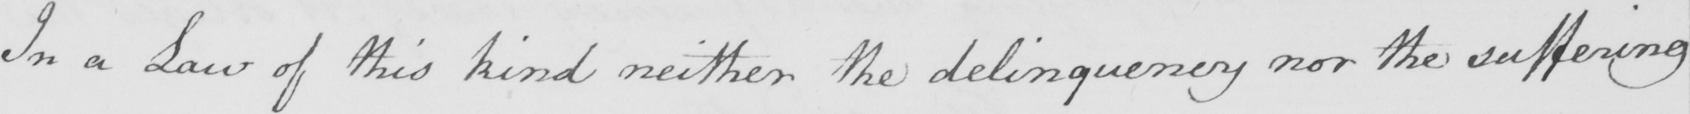Can you read and transcribe this handwriting? In a Law of this kind neither the delinquency nor the suffering 